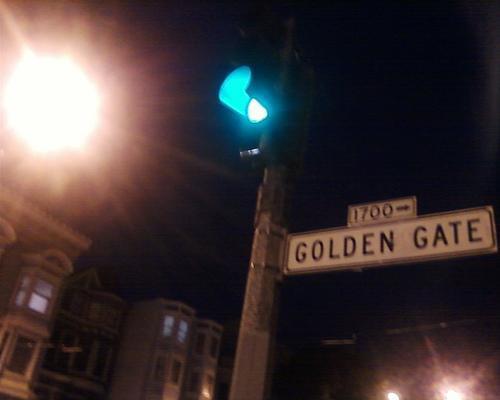How many signs are visible?
Give a very brief answer. 1. How many people have their arms outstretched?
Give a very brief answer. 0. 